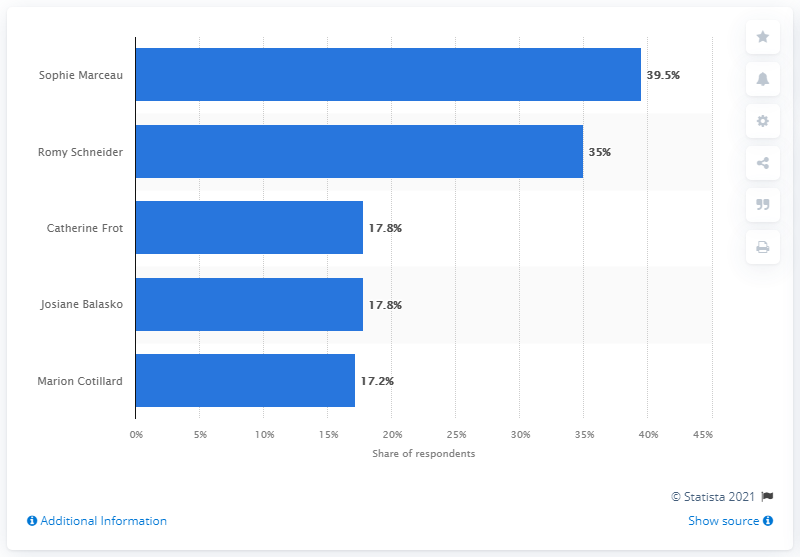Identify some key points in this picture. Romy Schneider is the second favorite French actress among individuals. The French actress Sophie Marceau has been ranked first in this list. 